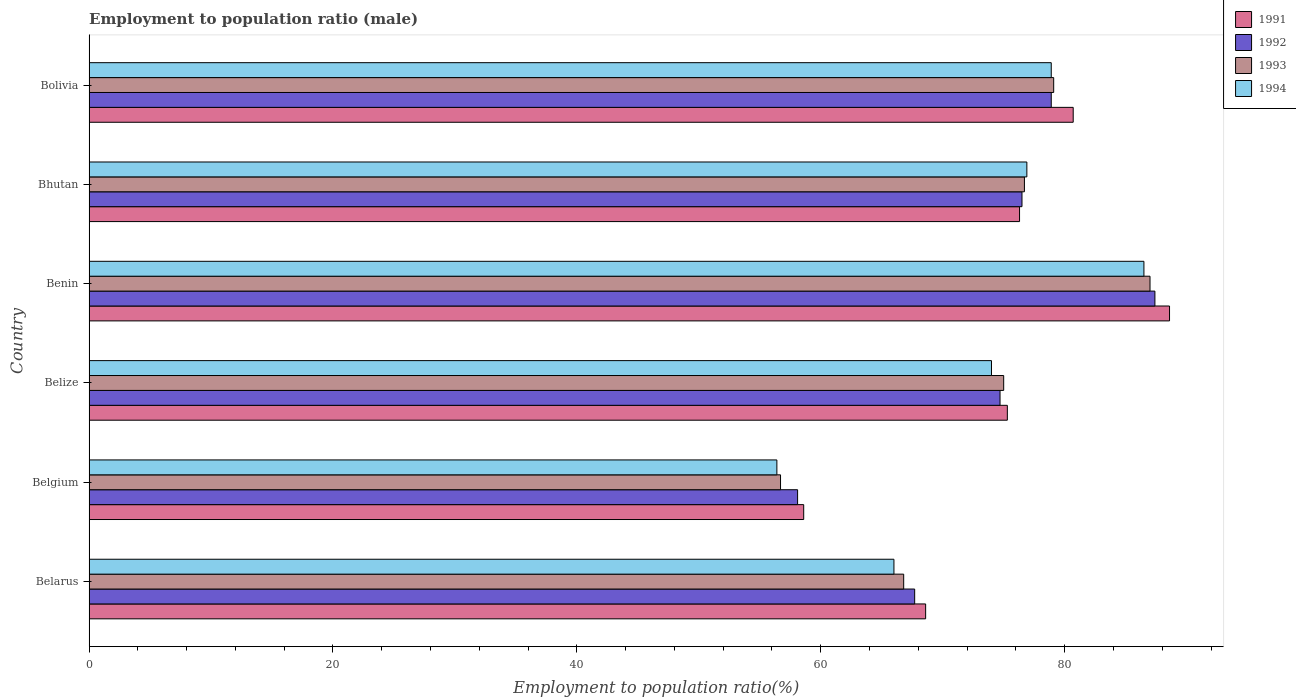How many different coloured bars are there?
Provide a short and direct response. 4. How many groups of bars are there?
Offer a very short reply. 6. Are the number of bars per tick equal to the number of legend labels?
Offer a very short reply. Yes. Are the number of bars on each tick of the Y-axis equal?
Your answer should be very brief. Yes. How many bars are there on the 5th tick from the top?
Offer a very short reply. 4. What is the label of the 1st group of bars from the top?
Your response must be concise. Bolivia. In how many cases, is the number of bars for a given country not equal to the number of legend labels?
Your answer should be very brief. 0. What is the employment to population ratio in 1991 in Benin?
Offer a terse response. 88.6. Across all countries, what is the maximum employment to population ratio in 1992?
Offer a terse response. 87.4. Across all countries, what is the minimum employment to population ratio in 1991?
Keep it short and to the point. 58.6. In which country was the employment to population ratio in 1993 maximum?
Keep it short and to the point. Benin. In which country was the employment to population ratio in 1992 minimum?
Keep it short and to the point. Belgium. What is the total employment to population ratio in 1991 in the graph?
Your response must be concise. 448.1. What is the difference between the employment to population ratio in 1991 in Belgium and that in Benin?
Provide a succinct answer. -30. What is the average employment to population ratio in 1991 per country?
Offer a terse response. 74.68. What is the difference between the employment to population ratio in 1991 and employment to population ratio in 1994 in Bhutan?
Your answer should be compact. -0.6. What is the ratio of the employment to population ratio in 1994 in Belize to that in Bolivia?
Offer a very short reply. 0.94. What is the difference between the highest and the second highest employment to population ratio in 1994?
Give a very brief answer. 7.6. What is the difference between the highest and the lowest employment to population ratio in 1993?
Your answer should be very brief. 30.3. In how many countries, is the employment to population ratio in 1992 greater than the average employment to population ratio in 1992 taken over all countries?
Give a very brief answer. 4. Is the sum of the employment to population ratio in 1994 in Belize and Bolivia greater than the maximum employment to population ratio in 1992 across all countries?
Keep it short and to the point. Yes. What does the 2nd bar from the bottom in Belize represents?
Keep it short and to the point. 1992. Is it the case that in every country, the sum of the employment to population ratio in 1994 and employment to population ratio in 1991 is greater than the employment to population ratio in 1993?
Offer a terse response. Yes. How many bars are there?
Offer a terse response. 24. What is the difference between two consecutive major ticks on the X-axis?
Your answer should be compact. 20. Does the graph contain grids?
Your answer should be compact. No. How many legend labels are there?
Your answer should be very brief. 4. What is the title of the graph?
Provide a succinct answer. Employment to population ratio (male). Does "2010" appear as one of the legend labels in the graph?
Your answer should be very brief. No. What is the label or title of the X-axis?
Ensure brevity in your answer.  Employment to population ratio(%). What is the label or title of the Y-axis?
Provide a short and direct response. Country. What is the Employment to population ratio(%) in 1991 in Belarus?
Ensure brevity in your answer.  68.6. What is the Employment to population ratio(%) of 1992 in Belarus?
Offer a very short reply. 67.7. What is the Employment to population ratio(%) of 1993 in Belarus?
Make the answer very short. 66.8. What is the Employment to population ratio(%) in 1991 in Belgium?
Your answer should be compact. 58.6. What is the Employment to population ratio(%) of 1992 in Belgium?
Your response must be concise. 58.1. What is the Employment to population ratio(%) in 1993 in Belgium?
Keep it short and to the point. 56.7. What is the Employment to population ratio(%) of 1994 in Belgium?
Your response must be concise. 56.4. What is the Employment to population ratio(%) in 1991 in Belize?
Your answer should be compact. 75.3. What is the Employment to population ratio(%) of 1992 in Belize?
Keep it short and to the point. 74.7. What is the Employment to population ratio(%) in 1994 in Belize?
Offer a very short reply. 74. What is the Employment to population ratio(%) in 1991 in Benin?
Provide a succinct answer. 88.6. What is the Employment to population ratio(%) of 1992 in Benin?
Provide a succinct answer. 87.4. What is the Employment to population ratio(%) in 1994 in Benin?
Keep it short and to the point. 86.5. What is the Employment to population ratio(%) of 1991 in Bhutan?
Offer a terse response. 76.3. What is the Employment to population ratio(%) in 1992 in Bhutan?
Provide a succinct answer. 76.5. What is the Employment to population ratio(%) in 1993 in Bhutan?
Your answer should be compact. 76.7. What is the Employment to population ratio(%) in 1994 in Bhutan?
Offer a very short reply. 76.9. What is the Employment to population ratio(%) in 1991 in Bolivia?
Your response must be concise. 80.7. What is the Employment to population ratio(%) in 1992 in Bolivia?
Offer a terse response. 78.9. What is the Employment to population ratio(%) of 1993 in Bolivia?
Your answer should be compact. 79.1. What is the Employment to population ratio(%) of 1994 in Bolivia?
Provide a short and direct response. 78.9. Across all countries, what is the maximum Employment to population ratio(%) in 1991?
Your answer should be very brief. 88.6. Across all countries, what is the maximum Employment to population ratio(%) of 1992?
Make the answer very short. 87.4. Across all countries, what is the maximum Employment to population ratio(%) of 1993?
Make the answer very short. 87. Across all countries, what is the maximum Employment to population ratio(%) in 1994?
Make the answer very short. 86.5. Across all countries, what is the minimum Employment to population ratio(%) of 1991?
Your response must be concise. 58.6. Across all countries, what is the minimum Employment to population ratio(%) of 1992?
Keep it short and to the point. 58.1. Across all countries, what is the minimum Employment to population ratio(%) of 1993?
Offer a terse response. 56.7. Across all countries, what is the minimum Employment to population ratio(%) in 1994?
Your answer should be compact. 56.4. What is the total Employment to population ratio(%) of 1991 in the graph?
Provide a short and direct response. 448.1. What is the total Employment to population ratio(%) in 1992 in the graph?
Ensure brevity in your answer.  443.3. What is the total Employment to population ratio(%) of 1993 in the graph?
Offer a terse response. 441.3. What is the total Employment to population ratio(%) of 1994 in the graph?
Offer a terse response. 438.7. What is the difference between the Employment to population ratio(%) of 1991 in Belarus and that in Belgium?
Give a very brief answer. 10. What is the difference between the Employment to population ratio(%) in 1993 in Belarus and that in Belgium?
Offer a very short reply. 10.1. What is the difference between the Employment to population ratio(%) of 1994 in Belarus and that in Belgium?
Offer a very short reply. 9.6. What is the difference between the Employment to population ratio(%) of 1992 in Belarus and that in Belize?
Offer a terse response. -7. What is the difference between the Employment to population ratio(%) of 1993 in Belarus and that in Belize?
Offer a terse response. -8.2. What is the difference between the Employment to population ratio(%) in 1992 in Belarus and that in Benin?
Your answer should be compact. -19.7. What is the difference between the Employment to population ratio(%) in 1993 in Belarus and that in Benin?
Keep it short and to the point. -20.2. What is the difference between the Employment to population ratio(%) in 1994 in Belarus and that in Benin?
Provide a succinct answer. -20.5. What is the difference between the Employment to population ratio(%) of 1991 in Belarus and that in Bhutan?
Your answer should be compact. -7.7. What is the difference between the Employment to population ratio(%) in 1992 in Belarus and that in Bhutan?
Your answer should be compact. -8.8. What is the difference between the Employment to population ratio(%) of 1993 in Belarus and that in Bhutan?
Give a very brief answer. -9.9. What is the difference between the Employment to population ratio(%) in 1994 in Belarus and that in Bhutan?
Give a very brief answer. -10.9. What is the difference between the Employment to population ratio(%) of 1991 in Belarus and that in Bolivia?
Offer a terse response. -12.1. What is the difference between the Employment to population ratio(%) of 1991 in Belgium and that in Belize?
Provide a succinct answer. -16.7. What is the difference between the Employment to population ratio(%) of 1992 in Belgium and that in Belize?
Offer a very short reply. -16.6. What is the difference between the Employment to population ratio(%) of 1993 in Belgium and that in Belize?
Provide a succinct answer. -18.3. What is the difference between the Employment to population ratio(%) in 1994 in Belgium and that in Belize?
Offer a terse response. -17.6. What is the difference between the Employment to population ratio(%) of 1991 in Belgium and that in Benin?
Provide a succinct answer. -30. What is the difference between the Employment to population ratio(%) of 1992 in Belgium and that in Benin?
Offer a very short reply. -29.3. What is the difference between the Employment to population ratio(%) of 1993 in Belgium and that in Benin?
Offer a terse response. -30.3. What is the difference between the Employment to population ratio(%) in 1994 in Belgium and that in Benin?
Provide a short and direct response. -30.1. What is the difference between the Employment to population ratio(%) in 1991 in Belgium and that in Bhutan?
Offer a very short reply. -17.7. What is the difference between the Employment to population ratio(%) in 1992 in Belgium and that in Bhutan?
Make the answer very short. -18.4. What is the difference between the Employment to population ratio(%) in 1993 in Belgium and that in Bhutan?
Offer a very short reply. -20. What is the difference between the Employment to population ratio(%) of 1994 in Belgium and that in Bhutan?
Make the answer very short. -20.5. What is the difference between the Employment to population ratio(%) of 1991 in Belgium and that in Bolivia?
Your answer should be very brief. -22.1. What is the difference between the Employment to population ratio(%) in 1992 in Belgium and that in Bolivia?
Your answer should be very brief. -20.8. What is the difference between the Employment to population ratio(%) of 1993 in Belgium and that in Bolivia?
Your response must be concise. -22.4. What is the difference between the Employment to population ratio(%) in 1994 in Belgium and that in Bolivia?
Your response must be concise. -22.5. What is the difference between the Employment to population ratio(%) of 1994 in Belize and that in Benin?
Your answer should be very brief. -12.5. What is the difference between the Employment to population ratio(%) of 1991 in Belize and that in Bhutan?
Your answer should be very brief. -1. What is the difference between the Employment to population ratio(%) of 1991 in Belize and that in Bolivia?
Offer a terse response. -5.4. What is the difference between the Employment to population ratio(%) of 1992 in Belize and that in Bolivia?
Make the answer very short. -4.2. What is the difference between the Employment to population ratio(%) in 1994 in Belize and that in Bolivia?
Ensure brevity in your answer.  -4.9. What is the difference between the Employment to population ratio(%) of 1991 in Benin and that in Bhutan?
Offer a very short reply. 12.3. What is the difference between the Employment to population ratio(%) in 1992 in Benin and that in Bhutan?
Give a very brief answer. 10.9. What is the difference between the Employment to population ratio(%) in 1993 in Benin and that in Bhutan?
Your response must be concise. 10.3. What is the difference between the Employment to population ratio(%) of 1994 in Benin and that in Bhutan?
Offer a terse response. 9.6. What is the difference between the Employment to population ratio(%) of 1991 in Benin and that in Bolivia?
Ensure brevity in your answer.  7.9. What is the difference between the Employment to population ratio(%) of 1993 in Benin and that in Bolivia?
Your answer should be very brief. 7.9. What is the difference between the Employment to population ratio(%) of 1992 in Bhutan and that in Bolivia?
Ensure brevity in your answer.  -2.4. What is the difference between the Employment to population ratio(%) of 1993 in Bhutan and that in Bolivia?
Your answer should be compact. -2.4. What is the difference between the Employment to population ratio(%) of 1992 in Belarus and the Employment to population ratio(%) of 1993 in Belgium?
Your answer should be compact. 11. What is the difference between the Employment to population ratio(%) of 1993 in Belarus and the Employment to population ratio(%) of 1994 in Belgium?
Offer a very short reply. 10.4. What is the difference between the Employment to population ratio(%) in 1991 in Belarus and the Employment to population ratio(%) in 1992 in Belize?
Your response must be concise. -6.1. What is the difference between the Employment to population ratio(%) in 1992 in Belarus and the Employment to population ratio(%) in 1993 in Belize?
Make the answer very short. -7.3. What is the difference between the Employment to population ratio(%) in 1991 in Belarus and the Employment to population ratio(%) in 1992 in Benin?
Provide a succinct answer. -18.8. What is the difference between the Employment to population ratio(%) in 1991 in Belarus and the Employment to population ratio(%) in 1993 in Benin?
Your answer should be compact. -18.4. What is the difference between the Employment to population ratio(%) in 1991 in Belarus and the Employment to population ratio(%) in 1994 in Benin?
Keep it short and to the point. -17.9. What is the difference between the Employment to population ratio(%) in 1992 in Belarus and the Employment to population ratio(%) in 1993 in Benin?
Your answer should be very brief. -19.3. What is the difference between the Employment to population ratio(%) of 1992 in Belarus and the Employment to population ratio(%) of 1994 in Benin?
Provide a succinct answer. -18.8. What is the difference between the Employment to population ratio(%) in 1993 in Belarus and the Employment to population ratio(%) in 1994 in Benin?
Give a very brief answer. -19.7. What is the difference between the Employment to population ratio(%) of 1991 in Belarus and the Employment to population ratio(%) of 1994 in Bhutan?
Make the answer very short. -8.3. What is the difference between the Employment to population ratio(%) in 1992 in Belarus and the Employment to population ratio(%) in 1994 in Bhutan?
Your response must be concise. -9.2. What is the difference between the Employment to population ratio(%) of 1993 in Belarus and the Employment to population ratio(%) of 1994 in Bhutan?
Make the answer very short. -10.1. What is the difference between the Employment to population ratio(%) of 1991 in Belarus and the Employment to population ratio(%) of 1992 in Bolivia?
Make the answer very short. -10.3. What is the difference between the Employment to population ratio(%) in 1991 in Belarus and the Employment to population ratio(%) in 1994 in Bolivia?
Provide a short and direct response. -10.3. What is the difference between the Employment to population ratio(%) of 1992 in Belarus and the Employment to population ratio(%) of 1993 in Bolivia?
Your response must be concise. -11.4. What is the difference between the Employment to population ratio(%) in 1992 in Belarus and the Employment to population ratio(%) in 1994 in Bolivia?
Provide a succinct answer. -11.2. What is the difference between the Employment to population ratio(%) of 1993 in Belarus and the Employment to population ratio(%) of 1994 in Bolivia?
Give a very brief answer. -12.1. What is the difference between the Employment to population ratio(%) in 1991 in Belgium and the Employment to population ratio(%) in 1992 in Belize?
Provide a succinct answer. -16.1. What is the difference between the Employment to population ratio(%) in 1991 in Belgium and the Employment to population ratio(%) in 1993 in Belize?
Provide a succinct answer. -16.4. What is the difference between the Employment to population ratio(%) of 1991 in Belgium and the Employment to population ratio(%) of 1994 in Belize?
Make the answer very short. -15.4. What is the difference between the Employment to population ratio(%) of 1992 in Belgium and the Employment to population ratio(%) of 1993 in Belize?
Your answer should be compact. -16.9. What is the difference between the Employment to population ratio(%) in 1992 in Belgium and the Employment to population ratio(%) in 1994 in Belize?
Your answer should be very brief. -15.9. What is the difference between the Employment to population ratio(%) in 1993 in Belgium and the Employment to population ratio(%) in 1994 in Belize?
Provide a succinct answer. -17.3. What is the difference between the Employment to population ratio(%) of 1991 in Belgium and the Employment to population ratio(%) of 1992 in Benin?
Your response must be concise. -28.8. What is the difference between the Employment to population ratio(%) in 1991 in Belgium and the Employment to population ratio(%) in 1993 in Benin?
Your answer should be very brief. -28.4. What is the difference between the Employment to population ratio(%) of 1991 in Belgium and the Employment to population ratio(%) of 1994 in Benin?
Your answer should be compact. -27.9. What is the difference between the Employment to population ratio(%) of 1992 in Belgium and the Employment to population ratio(%) of 1993 in Benin?
Ensure brevity in your answer.  -28.9. What is the difference between the Employment to population ratio(%) of 1992 in Belgium and the Employment to population ratio(%) of 1994 in Benin?
Your answer should be very brief. -28.4. What is the difference between the Employment to population ratio(%) in 1993 in Belgium and the Employment to population ratio(%) in 1994 in Benin?
Provide a succinct answer. -29.8. What is the difference between the Employment to population ratio(%) in 1991 in Belgium and the Employment to population ratio(%) in 1992 in Bhutan?
Offer a very short reply. -17.9. What is the difference between the Employment to population ratio(%) in 1991 in Belgium and the Employment to population ratio(%) in 1993 in Bhutan?
Your response must be concise. -18.1. What is the difference between the Employment to population ratio(%) in 1991 in Belgium and the Employment to population ratio(%) in 1994 in Bhutan?
Your answer should be very brief. -18.3. What is the difference between the Employment to population ratio(%) in 1992 in Belgium and the Employment to population ratio(%) in 1993 in Bhutan?
Give a very brief answer. -18.6. What is the difference between the Employment to population ratio(%) in 1992 in Belgium and the Employment to population ratio(%) in 1994 in Bhutan?
Offer a very short reply. -18.8. What is the difference between the Employment to population ratio(%) in 1993 in Belgium and the Employment to population ratio(%) in 1994 in Bhutan?
Make the answer very short. -20.2. What is the difference between the Employment to population ratio(%) in 1991 in Belgium and the Employment to population ratio(%) in 1992 in Bolivia?
Your answer should be very brief. -20.3. What is the difference between the Employment to population ratio(%) of 1991 in Belgium and the Employment to population ratio(%) of 1993 in Bolivia?
Offer a very short reply. -20.5. What is the difference between the Employment to population ratio(%) in 1991 in Belgium and the Employment to population ratio(%) in 1994 in Bolivia?
Your answer should be compact. -20.3. What is the difference between the Employment to population ratio(%) in 1992 in Belgium and the Employment to population ratio(%) in 1994 in Bolivia?
Your answer should be very brief. -20.8. What is the difference between the Employment to population ratio(%) of 1993 in Belgium and the Employment to population ratio(%) of 1994 in Bolivia?
Keep it short and to the point. -22.2. What is the difference between the Employment to population ratio(%) in 1991 in Belize and the Employment to population ratio(%) in 1992 in Benin?
Make the answer very short. -12.1. What is the difference between the Employment to population ratio(%) in 1991 in Belize and the Employment to population ratio(%) in 1992 in Bhutan?
Give a very brief answer. -1.2. What is the difference between the Employment to population ratio(%) in 1991 in Belize and the Employment to population ratio(%) in 1993 in Bhutan?
Offer a very short reply. -1.4. What is the difference between the Employment to population ratio(%) in 1993 in Belize and the Employment to population ratio(%) in 1994 in Bhutan?
Offer a very short reply. -1.9. What is the difference between the Employment to population ratio(%) in 1991 in Belize and the Employment to population ratio(%) in 1994 in Bolivia?
Give a very brief answer. -3.6. What is the difference between the Employment to population ratio(%) of 1992 in Belize and the Employment to population ratio(%) of 1993 in Bolivia?
Offer a very short reply. -4.4. What is the difference between the Employment to population ratio(%) in 1993 in Belize and the Employment to population ratio(%) in 1994 in Bolivia?
Provide a succinct answer. -3.9. What is the difference between the Employment to population ratio(%) in 1993 in Benin and the Employment to population ratio(%) in 1994 in Bhutan?
Your response must be concise. 10.1. What is the difference between the Employment to population ratio(%) of 1991 in Benin and the Employment to population ratio(%) of 1992 in Bolivia?
Provide a short and direct response. 9.7. What is the difference between the Employment to population ratio(%) in 1991 in Benin and the Employment to population ratio(%) in 1993 in Bolivia?
Provide a succinct answer. 9.5. What is the difference between the Employment to population ratio(%) in 1991 in Benin and the Employment to population ratio(%) in 1994 in Bolivia?
Your answer should be compact. 9.7. What is the difference between the Employment to population ratio(%) in 1992 in Benin and the Employment to population ratio(%) in 1994 in Bolivia?
Provide a succinct answer. 8.5. What is the difference between the Employment to population ratio(%) in 1993 in Benin and the Employment to population ratio(%) in 1994 in Bolivia?
Keep it short and to the point. 8.1. What is the difference between the Employment to population ratio(%) in 1991 in Bhutan and the Employment to population ratio(%) in 1993 in Bolivia?
Ensure brevity in your answer.  -2.8. What is the difference between the Employment to population ratio(%) of 1991 in Bhutan and the Employment to population ratio(%) of 1994 in Bolivia?
Provide a short and direct response. -2.6. What is the average Employment to population ratio(%) in 1991 per country?
Give a very brief answer. 74.68. What is the average Employment to population ratio(%) of 1992 per country?
Your response must be concise. 73.88. What is the average Employment to population ratio(%) of 1993 per country?
Offer a terse response. 73.55. What is the average Employment to population ratio(%) of 1994 per country?
Offer a very short reply. 73.12. What is the difference between the Employment to population ratio(%) in 1991 and Employment to population ratio(%) in 1992 in Belarus?
Your response must be concise. 0.9. What is the difference between the Employment to population ratio(%) in 1992 and Employment to population ratio(%) in 1994 in Belgium?
Make the answer very short. 1.7. What is the difference between the Employment to population ratio(%) in 1993 and Employment to population ratio(%) in 1994 in Belgium?
Ensure brevity in your answer.  0.3. What is the difference between the Employment to population ratio(%) of 1991 and Employment to population ratio(%) of 1992 in Belize?
Ensure brevity in your answer.  0.6. What is the difference between the Employment to population ratio(%) in 1992 and Employment to population ratio(%) in 1993 in Belize?
Your answer should be very brief. -0.3. What is the difference between the Employment to population ratio(%) in 1991 and Employment to population ratio(%) in 1992 in Benin?
Provide a short and direct response. 1.2. What is the difference between the Employment to population ratio(%) of 1993 and Employment to population ratio(%) of 1994 in Benin?
Provide a succinct answer. 0.5. What is the difference between the Employment to population ratio(%) of 1991 and Employment to population ratio(%) of 1992 in Bhutan?
Your answer should be compact. -0.2. What is the difference between the Employment to population ratio(%) of 1991 and Employment to population ratio(%) of 1993 in Bhutan?
Offer a terse response. -0.4. What is the difference between the Employment to population ratio(%) of 1992 and Employment to population ratio(%) of 1993 in Bhutan?
Your answer should be very brief. -0.2. What is the difference between the Employment to population ratio(%) of 1993 and Employment to population ratio(%) of 1994 in Bhutan?
Give a very brief answer. -0.2. What is the difference between the Employment to population ratio(%) in 1991 and Employment to population ratio(%) in 1992 in Bolivia?
Provide a short and direct response. 1.8. What is the difference between the Employment to population ratio(%) in 1992 and Employment to population ratio(%) in 1994 in Bolivia?
Your answer should be very brief. 0. What is the ratio of the Employment to population ratio(%) of 1991 in Belarus to that in Belgium?
Keep it short and to the point. 1.17. What is the ratio of the Employment to population ratio(%) of 1992 in Belarus to that in Belgium?
Keep it short and to the point. 1.17. What is the ratio of the Employment to population ratio(%) of 1993 in Belarus to that in Belgium?
Offer a terse response. 1.18. What is the ratio of the Employment to population ratio(%) in 1994 in Belarus to that in Belgium?
Provide a succinct answer. 1.17. What is the ratio of the Employment to population ratio(%) of 1991 in Belarus to that in Belize?
Offer a very short reply. 0.91. What is the ratio of the Employment to population ratio(%) in 1992 in Belarus to that in Belize?
Provide a succinct answer. 0.91. What is the ratio of the Employment to population ratio(%) of 1993 in Belarus to that in Belize?
Keep it short and to the point. 0.89. What is the ratio of the Employment to population ratio(%) of 1994 in Belarus to that in Belize?
Offer a very short reply. 0.89. What is the ratio of the Employment to population ratio(%) of 1991 in Belarus to that in Benin?
Your answer should be very brief. 0.77. What is the ratio of the Employment to population ratio(%) in 1992 in Belarus to that in Benin?
Make the answer very short. 0.77. What is the ratio of the Employment to population ratio(%) in 1993 in Belarus to that in Benin?
Give a very brief answer. 0.77. What is the ratio of the Employment to population ratio(%) of 1994 in Belarus to that in Benin?
Make the answer very short. 0.76. What is the ratio of the Employment to population ratio(%) in 1991 in Belarus to that in Bhutan?
Offer a very short reply. 0.9. What is the ratio of the Employment to population ratio(%) in 1992 in Belarus to that in Bhutan?
Provide a succinct answer. 0.89. What is the ratio of the Employment to population ratio(%) in 1993 in Belarus to that in Bhutan?
Offer a very short reply. 0.87. What is the ratio of the Employment to population ratio(%) in 1994 in Belarus to that in Bhutan?
Make the answer very short. 0.86. What is the ratio of the Employment to population ratio(%) in 1991 in Belarus to that in Bolivia?
Provide a succinct answer. 0.85. What is the ratio of the Employment to population ratio(%) in 1992 in Belarus to that in Bolivia?
Offer a very short reply. 0.86. What is the ratio of the Employment to population ratio(%) in 1993 in Belarus to that in Bolivia?
Your response must be concise. 0.84. What is the ratio of the Employment to population ratio(%) of 1994 in Belarus to that in Bolivia?
Your response must be concise. 0.84. What is the ratio of the Employment to population ratio(%) of 1991 in Belgium to that in Belize?
Offer a very short reply. 0.78. What is the ratio of the Employment to population ratio(%) of 1993 in Belgium to that in Belize?
Keep it short and to the point. 0.76. What is the ratio of the Employment to population ratio(%) in 1994 in Belgium to that in Belize?
Provide a short and direct response. 0.76. What is the ratio of the Employment to population ratio(%) in 1991 in Belgium to that in Benin?
Your answer should be very brief. 0.66. What is the ratio of the Employment to population ratio(%) of 1992 in Belgium to that in Benin?
Make the answer very short. 0.66. What is the ratio of the Employment to population ratio(%) of 1993 in Belgium to that in Benin?
Your answer should be very brief. 0.65. What is the ratio of the Employment to population ratio(%) of 1994 in Belgium to that in Benin?
Your response must be concise. 0.65. What is the ratio of the Employment to population ratio(%) of 1991 in Belgium to that in Bhutan?
Offer a very short reply. 0.77. What is the ratio of the Employment to population ratio(%) of 1992 in Belgium to that in Bhutan?
Provide a succinct answer. 0.76. What is the ratio of the Employment to population ratio(%) of 1993 in Belgium to that in Bhutan?
Ensure brevity in your answer.  0.74. What is the ratio of the Employment to population ratio(%) of 1994 in Belgium to that in Bhutan?
Provide a succinct answer. 0.73. What is the ratio of the Employment to population ratio(%) in 1991 in Belgium to that in Bolivia?
Offer a very short reply. 0.73. What is the ratio of the Employment to population ratio(%) in 1992 in Belgium to that in Bolivia?
Offer a terse response. 0.74. What is the ratio of the Employment to population ratio(%) of 1993 in Belgium to that in Bolivia?
Give a very brief answer. 0.72. What is the ratio of the Employment to population ratio(%) in 1994 in Belgium to that in Bolivia?
Your response must be concise. 0.71. What is the ratio of the Employment to population ratio(%) of 1991 in Belize to that in Benin?
Provide a short and direct response. 0.85. What is the ratio of the Employment to population ratio(%) of 1992 in Belize to that in Benin?
Provide a succinct answer. 0.85. What is the ratio of the Employment to population ratio(%) of 1993 in Belize to that in Benin?
Make the answer very short. 0.86. What is the ratio of the Employment to population ratio(%) of 1994 in Belize to that in Benin?
Offer a very short reply. 0.86. What is the ratio of the Employment to population ratio(%) of 1991 in Belize to that in Bhutan?
Make the answer very short. 0.99. What is the ratio of the Employment to population ratio(%) in 1992 in Belize to that in Bhutan?
Provide a succinct answer. 0.98. What is the ratio of the Employment to population ratio(%) of 1993 in Belize to that in Bhutan?
Give a very brief answer. 0.98. What is the ratio of the Employment to population ratio(%) in 1994 in Belize to that in Bhutan?
Your answer should be very brief. 0.96. What is the ratio of the Employment to population ratio(%) of 1991 in Belize to that in Bolivia?
Offer a very short reply. 0.93. What is the ratio of the Employment to population ratio(%) in 1992 in Belize to that in Bolivia?
Your answer should be compact. 0.95. What is the ratio of the Employment to population ratio(%) of 1993 in Belize to that in Bolivia?
Your response must be concise. 0.95. What is the ratio of the Employment to population ratio(%) in 1994 in Belize to that in Bolivia?
Provide a succinct answer. 0.94. What is the ratio of the Employment to population ratio(%) in 1991 in Benin to that in Bhutan?
Offer a terse response. 1.16. What is the ratio of the Employment to population ratio(%) in 1992 in Benin to that in Bhutan?
Offer a very short reply. 1.14. What is the ratio of the Employment to population ratio(%) in 1993 in Benin to that in Bhutan?
Keep it short and to the point. 1.13. What is the ratio of the Employment to population ratio(%) in 1994 in Benin to that in Bhutan?
Give a very brief answer. 1.12. What is the ratio of the Employment to population ratio(%) in 1991 in Benin to that in Bolivia?
Keep it short and to the point. 1.1. What is the ratio of the Employment to population ratio(%) in 1992 in Benin to that in Bolivia?
Keep it short and to the point. 1.11. What is the ratio of the Employment to population ratio(%) in 1993 in Benin to that in Bolivia?
Keep it short and to the point. 1.1. What is the ratio of the Employment to population ratio(%) in 1994 in Benin to that in Bolivia?
Your answer should be compact. 1.1. What is the ratio of the Employment to population ratio(%) of 1991 in Bhutan to that in Bolivia?
Make the answer very short. 0.95. What is the ratio of the Employment to population ratio(%) of 1992 in Bhutan to that in Bolivia?
Make the answer very short. 0.97. What is the ratio of the Employment to population ratio(%) of 1993 in Bhutan to that in Bolivia?
Give a very brief answer. 0.97. What is the ratio of the Employment to population ratio(%) of 1994 in Bhutan to that in Bolivia?
Your answer should be compact. 0.97. What is the difference between the highest and the second highest Employment to population ratio(%) of 1992?
Ensure brevity in your answer.  8.5. What is the difference between the highest and the second highest Employment to population ratio(%) of 1993?
Your answer should be very brief. 7.9. What is the difference between the highest and the second highest Employment to population ratio(%) of 1994?
Offer a terse response. 7.6. What is the difference between the highest and the lowest Employment to population ratio(%) in 1992?
Ensure brevity in your answer.  29.3. What is the difference between the highest and the lowest Employment to population ratio(%) in 1993?
Make the answer very short. 30.3. What is the difference between the highest and the lowest Employment to population ratio(%) in 1994?
Provide a short and direct response. 30.1. 